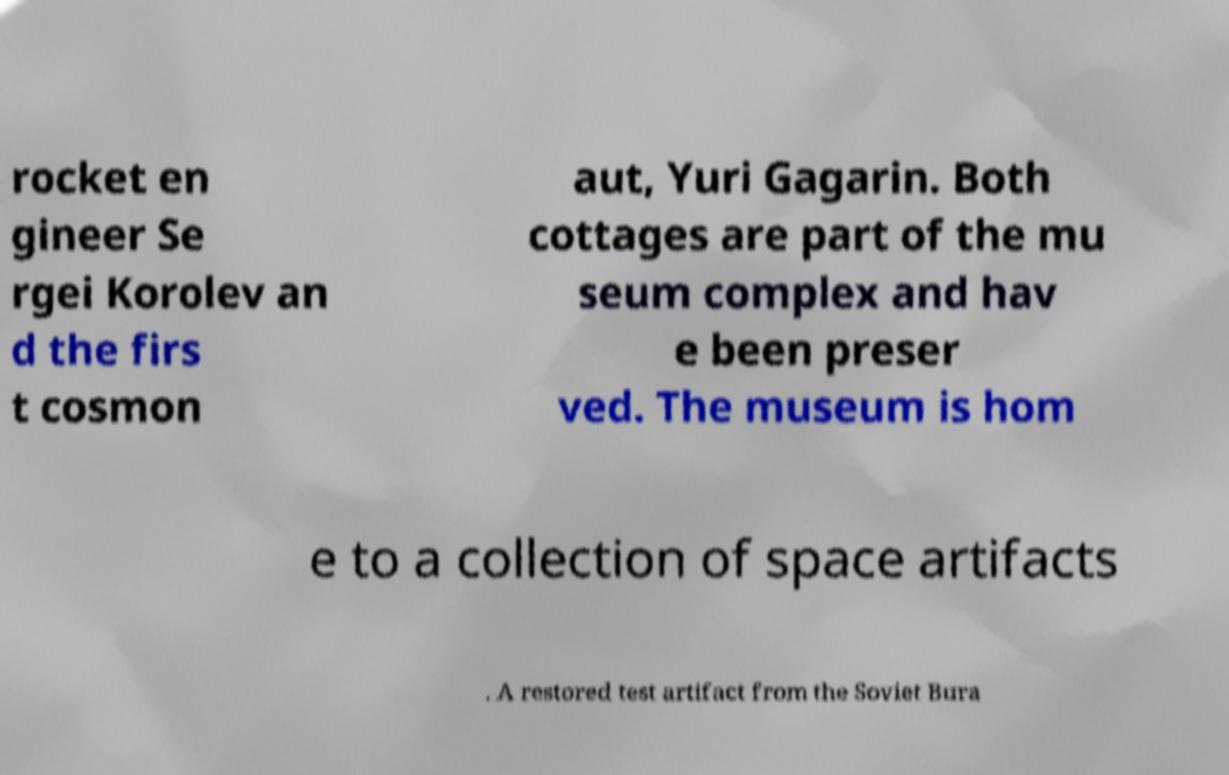Could you assist in decoding the text presented in this image and type it out clearly? rocket en gineer Se rgei Korolev an d the firs t cosmon aut, Yuri Gagarin. Both cottages are part of the mu seum complex and hav e been preser ved. The museum is hom e to a collection of space artifacts . A restored test artifact from the Soviet Bura 